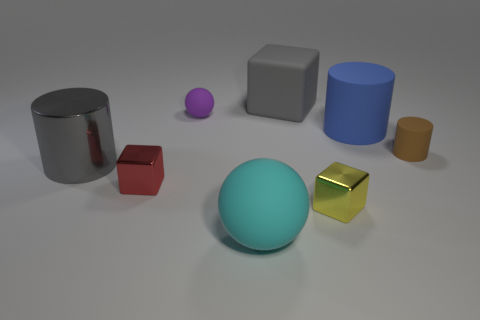How many metallic objects are the same color as the large block?
Provide a succinct answer. 1. What material is the gray thing left of the matte ball in front of the small metal block that is right of the red block?
Make the answer very short. Metal. How many blue objects are either spheres or big rubber blocks?
Provide a short and direct response. 0. There is a blue thing that is to the right of the cylinder left of the gray object that is to the right of the big matte ball; how big is it?
Your answer should be compact. Large. What size is the rubber thing that is the same shape as the tiny red shiny thing?
Offer a terse response. Large. What number of big things are green cylinders or blue cylinders?
Offer a very short reply. 1. Is the big gray thing in front of the brown cylinder made of the same material as the ball that is behind the small rubber cylinder?
Provide a succinct answer. No. There is a gray thing that is in front of the large blue matte thing; what material is it?
Provide a succinct answer. Metal. How many shiny objects are either spheres or cylinders?
Ensure brevity in your answer.  1. The large thing that is in front of the large cylinder that is to the left of the tiny yellow metallic block is what color?
Offer a very short reply. Cyan. 